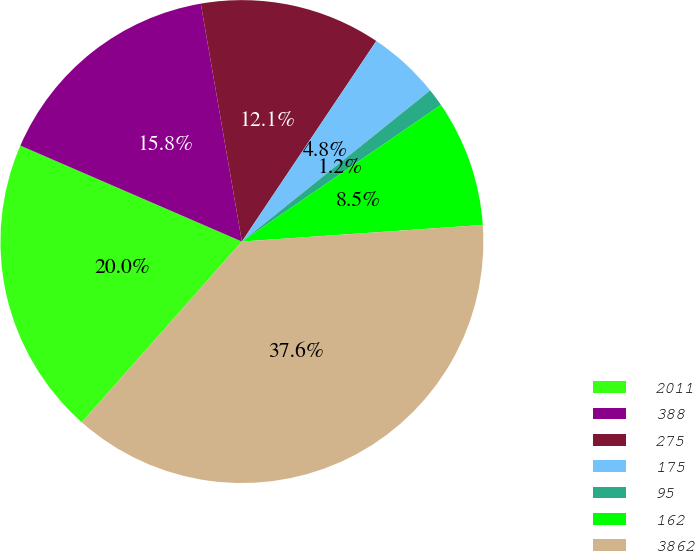<chart> <loc_0><loc_0><loc_500><loc_500><pie_chart><fcel>2011<fcel>388<fcel>275<fcel>175<fcel>95<fcel>162<fcel>3862<nl><fcel>19.97%<fcel>15.77%<fcel>12.12%<fcel>4.84%<fcel>1.19%<fcel>8.48%<fcel>37.63%<nl></chart> 